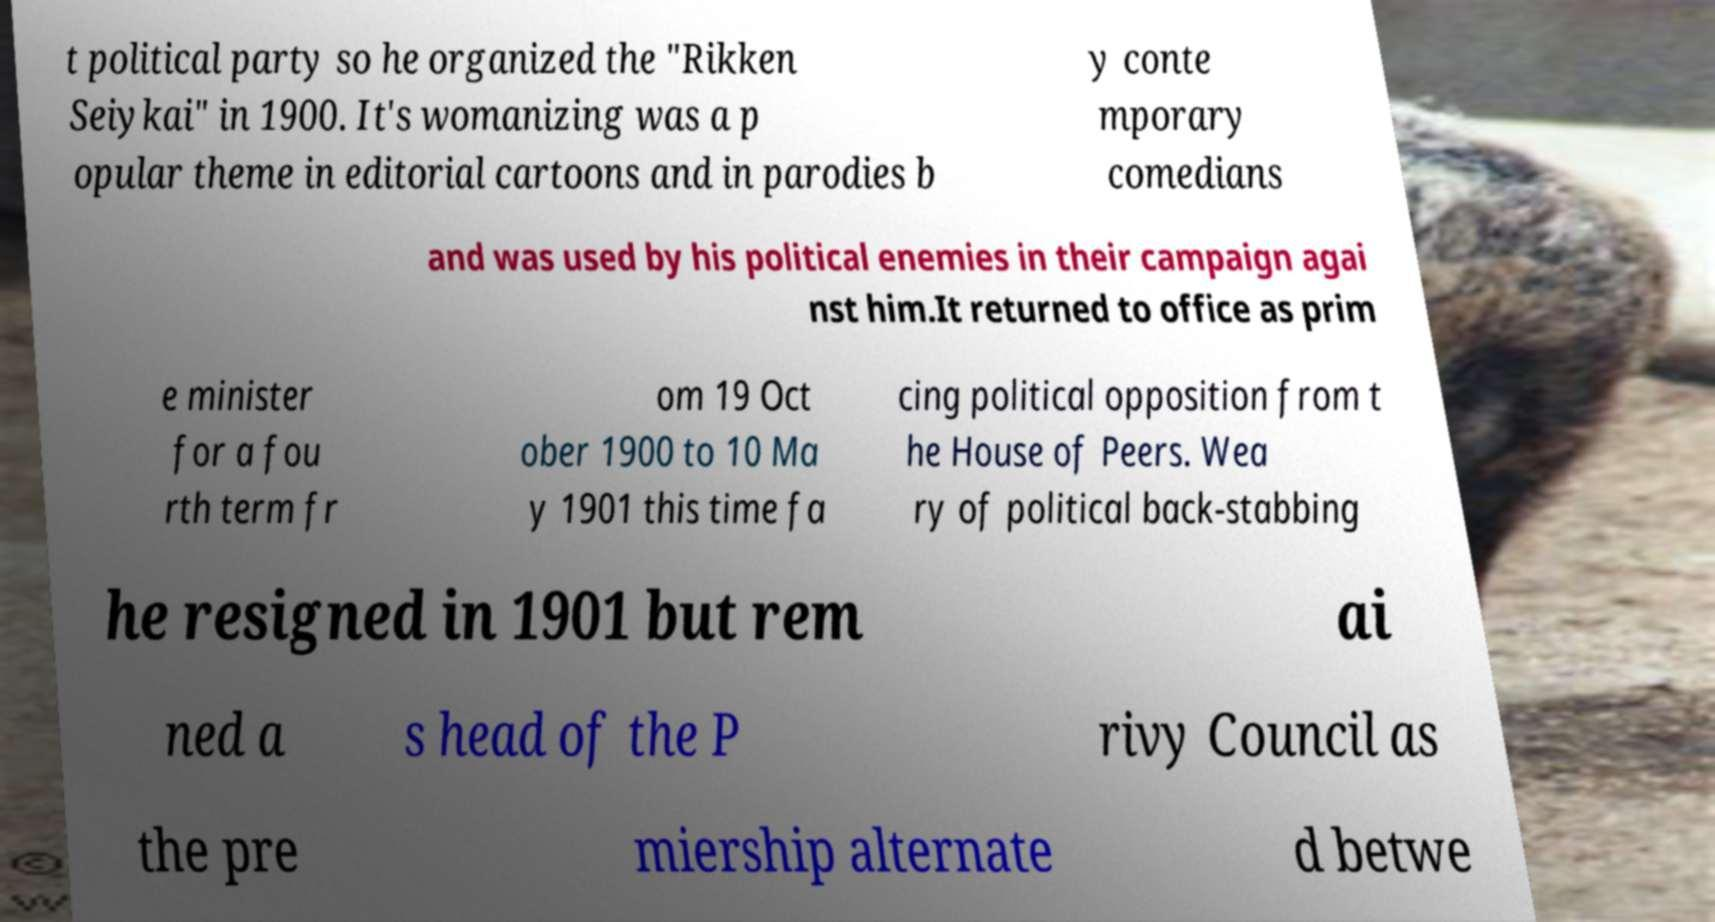What messages or text are displayed in this image? I need them in a readable, typed format. t political party so he organized the "Rikken Seiykai" in 1900. It's womanizing was a p opular theme in editorial cartoons and in parodies b y conte mporary comedians and was used by his political enemies in their campaign agai nst him.It returned to office as prim e minister for a fou rth term fr om 19 Oct ober 1900 to 10 Ma y 1901 this time fa cing political opposition from t he House of Peers. Wea ry of political back-stabbing he resigned in 1901 but rem ai ned a s head of the P rivy Council as the pre miership alternate d betwe 